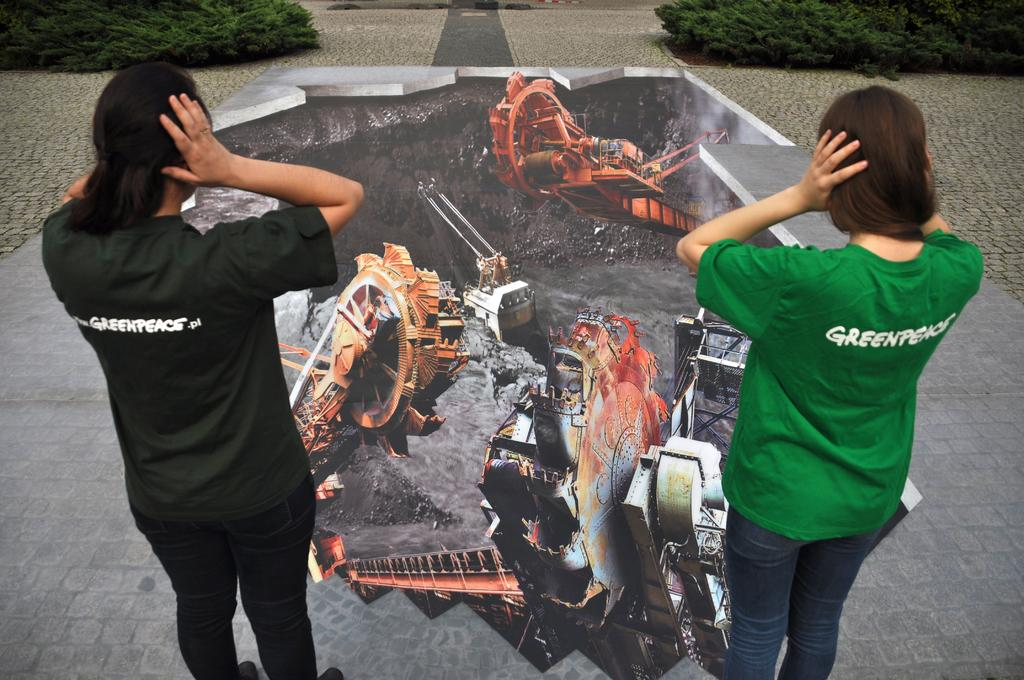<image>
Summarize the visual content of the image. Two people holding their ears, the woman and man are wearing a greenpeace shirt. 